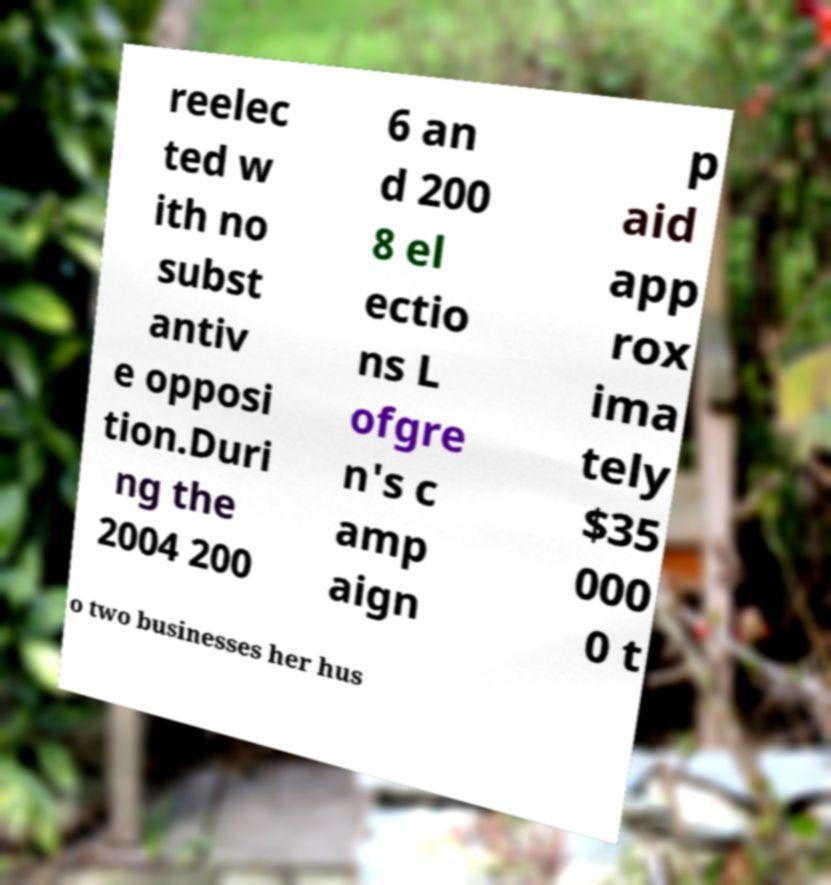Can you read and provide the text displayed in the image?This photo seems to have some interesting text. Can you extract and type it out for me? reelec ted w ith no subst antiv e opposi tion.Duri ng the 2004 200 6 an d 200 8 el ectio ns L ofgre n's c amp aign p aid app rox ima tely $35 000 0 t o two businesses her hus 